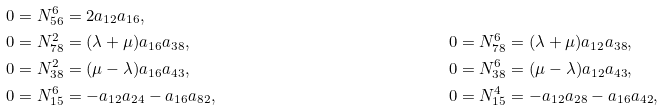<formula> <loc_0><loc_0><loc_500><loc_500>& 0 = N _ { 5 6 } ^ { 6 } = 2 a _ { 1 2 } a _ { 1 6 } , & & \\ & 0 = N _ { 7 8 } ^ { 2 } = ( \lambda + \mu ) a _ { 1 6 } a _ { 3 8 } , & & 0 = N _ { 7 8 } ^ { 6 } = ( \lambda + \mu ) a _ { 1 2 } a _ { 3 8 } , \\ & 0 = N _ { 3 8 } ^ { 2 } = ( \mu - \lambda ) a _ { 1 6 } a _ { 4 3 } , & & 0 = N _ { 3 8 } ^ { 6 } = ( \mu - \lambda ) a _ { 1 2 } a _ { 4 3 } , \\ & 0 = N _ { 1 5 } ^ { 6 } = - a _ { 1 2 } a _ { 2 4 } - a _ { 1 6 } a _ { 8 2 } , & & 0 = N _ { 1 5 } ^ { 4 } = - a _ { 1 2 } a _ { 2 8 } - a _ { 1 6 } a _ { 4 2 } ,</formula> 